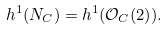<formula> <loc_0><loc_0><loc_500><loc_500>h ^ { 1 } ( N _ { C } ) = h ^ { 1 } ( \mathcal { O } _ { C } ( 2 ) ) .</formula> 